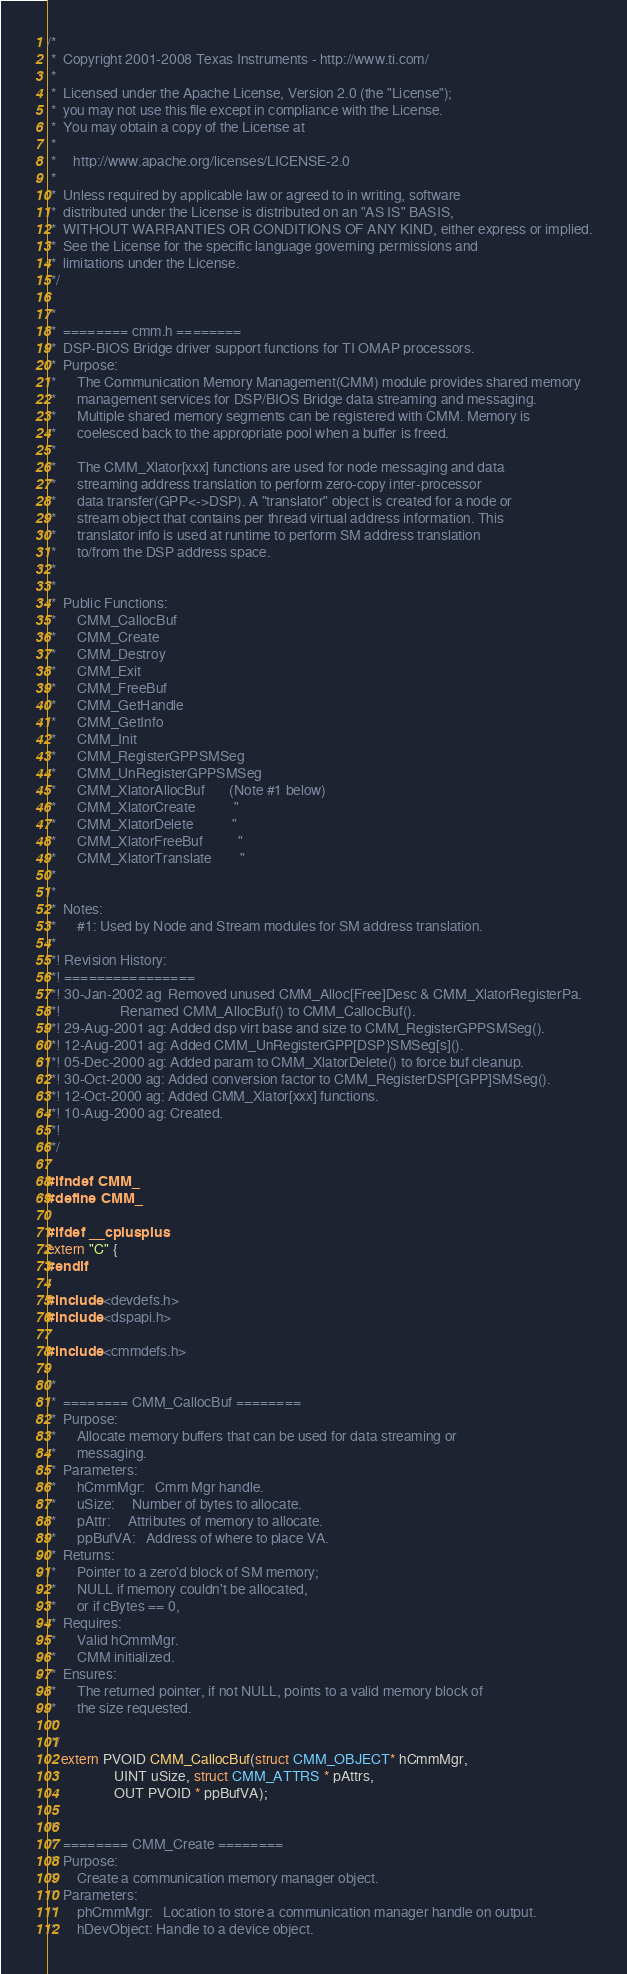<code> <loc_0><loc_0><loc_500><loc_500><_C_>/*
 *  Copyright 2001-2008 Texas Instruments - http://www.ti.com/
 * 
 *  Licensed under the Apache License, Version 2.0 (the "License");
 *  you may not use this file except in compliance with the License.
 *  You may obtain a copy of the License at
 * 
 *     http://www.apache.org/licenses/LICENSE-2.0
 * 
 *  Unless required by applicable law or agreed to in writing, software
 *  distributed under the License is distributed on an "AS IS" BASIS,
 *  WITHOUT WARRANTIES OR CONDITIONS OF ANY KIND, either express or implied.
 *  See the License for the specific language governing permissions and
 *  limitations under the License.
 */

/*
 *  ======== cmm.h ========
 *  DSP-BIOS Bridge driver support functions for TI OMAP processors.
 *  Purpose:
 *      The Communication Memory Management(CMM) module provides shared memory
 *      management services for DSP/BIOS Bridge data streaming and messaging.
 *      Multiple shared memory segments can be registered with CMM. Memory is
 *      coelesced back to the appropriate pool when a buffer is freed.
 *
 *      The CMM_Xlator[xxx] functions are used for node messaging and data
 *      streaming address translation to perform zero-copy inter-processor
 *      data transfer(GPP<->DSP). A "translator" object is created for a node or
 *      stream object that contains per thread virtual address information. This
 *      translator info is used at runtime to perform SM address translation
 *      to/from the DSP address space.
 *
 *
 *  Public Functions:
 *      CMM_CallocBuf
 *      CMM_Create
 *      CMM_Destroy
 *      CMM_Exit
 *      CMM_FreeBuf
 *      CMM_GetHandle
 *      CMM_GetInfo
 *      CMM_Init
 *      CMM_RegisterGPPSMSeg
 *      CMM_UnRegisterGPPSMSeg
 *      CMM_XlatorAllocBuf       (Note #1 below)
 *      CMM_XlatorCreate           "
 *      CMM_XlatorDelete           "
 *      CMM_XlatorFreeBuf          "
 *      CMM_XlatorTranslate        "
 *
 *
 *  Notes:
 *      #1: Used by Node and Stream modules for SM address translation.
 *
 *! Revision History:
 *! ================
 *! 30-Jan-2002 ag  Removed unused CMM_Alloc[Free]Desc & CMM_XlatorRegisterPa.
 *!                 Renamed CMM_AllocBuf() to CMM_CallocBuf().
 *! 29-Aug-2001 ag: Added dsp virt base and size to CMM_RegisterGPPSMSeg().
 *! 12-Aug-2001 ag: Added CMM_UnRegisterGPP[DSP}SMSeg[s]().
 *! 05-Dec-2000 ag: Added param to CMM_XlatorDelete() to force buf cleanup.
 *! 30-Oct-2000 ag: Added conversion factor to CMM_RegisterDSP[GPP]SMSeg().
 *! 12-Oct-2000 ag: Added CMM_Xlator[xxx] functions.
 *! 10-Aug-2000 ag: Created.
 *!
 */

#ifndef CMM_
#define CMM_

#ifdef __cplusplus
extern "C" {
#endif

#include <devdefs.h>
#include <dspapi.h>

#include <cmmdefs.h>

/*
 *  ======== CMM_CallocBuf ========
 *  Purpose:
 *      Allocate memory buffers that can be used for data streaming or
 *      messaging.
 *  Parameters:
 *      hCmmMgr:   Cmm Mgr handle.
 *      uSize:     Number of bytes to allocate.
 *      pAttr:     Attributes of memory to allocate.
 *      ppBufVA:   Address of where to place VA.
 *  Returns:
 *      Pointer to a zero'd block of SM memory;
 *      NULL if memory couldn't be allocated,
 *      or if cBytes == 0,
 *  Requires:
 *      Valid hCmmMgr.
 *      CMM initialized.
 *  Ensures:
 *      The returned pointer, if not NULL, points to a valid memory block of
 *      the size requested.
 *
 */
	extern PVOID CMM_CallocBuf(struct CMM_OBJECT* hCmmMgr,
				   UINT uSize, struct CMM_ATTRS * pAttrs,
				   OUT PVOID * ppBufVA);

/*
 *  ======== CMM_Create ========
 *  Purpose:
 *      Create a communication memory manager object.
 *  Parameters:
 *      phCmmMgr:   Location to store a communication manager handle on output.
 *      hDevObject: Handle to a device object.</code> 